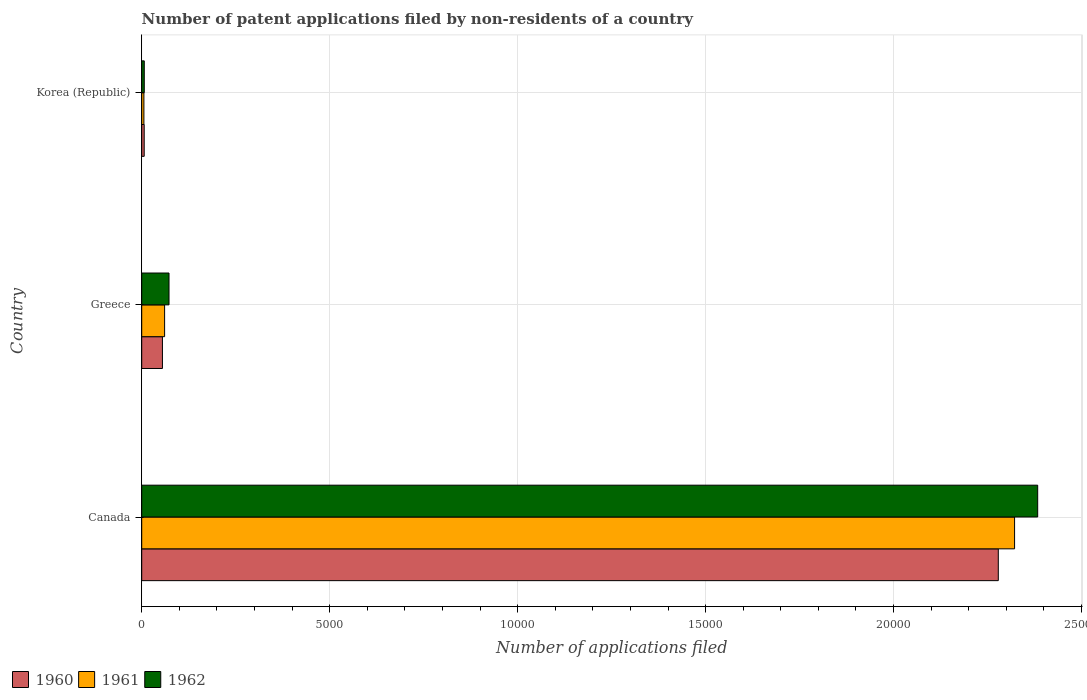How many different coloured bars are there?
Ensure brevity in your answer.  3. How many groups of bars are there?
Your answer should be very brief. 3. How many bars are there on the 1st tick from the top?
Offer a terse response. 3. What is the label of the 1st group of bars from the top?
Provide a succinct answer. Korea (Republic). In how many cases, is the number of bars for a given country not equal to the number of legend labels?
Ensure brevity in your answer.  0. What is the number of applications filed in 1962 in Korea (Republic)?
Offer a terse response. 68. Across all countries, what is the maximum number of applications filed in 1960?
Provide a short and direct response. 2.28e+04. In which country was the number of applications filed in 1962 maximum?
Make the answer very short. Canada. In which country was the number of applications filed in 1960 minimum?
Keep it short and to the point. Korea (Republic). What is the total number of applications filed in 1961 in the graph?
Give a very brief answer. 2.39e+04. What is the difference between the number of applications filed in 1961 in Canada and that in Greece?
Your answer should be compact. 2.26e+04. What is the difference between the number of applications filed in 1961 in Canada and the number of applications filed in 1960 in Korea (Republic)?
Your response must be concise. 2.32e+04. What is the average number of applications filed in 1960 per country?
Ensure brevity in your answer.  7801. What is the difference between the number of applications filed in 1960 and number of applications filed in 1961 in Korea (Republic)?
Your answer should be very brief. 8. What is the ratio of the number of applications filed in 1960 in Greece to that in Korea (Republic)?
Provide a short and direct response. 8.35. What is the difference between the highest and the second highest number of applications filed in 1962?
Give a very brief answer. 2.31e+04. What is the difference between the highest and the lowest number of applications filed in 1960?
Offer a terse response. 2.27e+04. Are all the bars in the graph horizontal?
Give a very brief answer. Yes. Are the values on the major ticks of X-axis written in scientific E-notation?
Offer a very short reply. No. Where does the legend appear in the graph?
Your answer should be compact. Bottom left. How many legend labels are there?
Your response must be concise. 3. What is the title of the graph?
Offer a very short reply. Number of patent applications filed by non-residents of a country. What is the label or title of the X-axis?
Ensure brevity in your answer.  Number of applications filed. What is the label or title of the Y-axis?
Ensure brevity in your answer.  Country. What is the Number of applications filed in 1960 in Canada?
Offer a terse response. 2.28e+04. What is the Number of applications filed in 1961 in Canada?
Provide a short and direct response. 2.32e+04. What is the Number of applications filed of 1962 in Canada?
Offer a very short reply. 2.38e+04. What is the Number of applications filed in 1960 in Greece?
Keep it short and to the point. 551. What is the Number of applications filed of 1961 in Greece?
Your answer should be compact. 609. What is the Number of applications filed in 1962 in Greece?
Offer a very short reply. 726. What is the Number of applications filed of 1961 in Korea (Republic)?
Ensure brevity in your answer.  58. What is the Number of applications filed in 1962 in Korea (Republic)?
Ensure brevity in your answer.  68. Across all countries, what is the maximum Number of applications filed of 1960?
Ensure brevity in your answer.  2.28e+04. Across all countries, what is the maximum Number of applications filed in 1961?
Offer a very short reply. 2.32e+04. Across all countries, what is the maximum Number of applications filed of 1962?
Offer a very short reply. 2.38e+04. Across all countries, what is the minimum Number of applications filed in 1960?
Your response must be concise. 66. Across all countries, what is the minimum Number of applications filed in 1962?
Your answer should be compact. 68. What is the total Number of applications filed in 1960 in the graph?
Your answer should be very brief. 2.34e+04. What is the total Number of applications filed of 1961 in the graph?
Keep it short and to the point. 2.39e+04. What is the total Number of applications filed of 1962 in the graph?
Your response must be concise. 2.46e+04. What is the difference between the Number of applications filed of 1960 in Canada and that in Greece?
Your response must be concise. 2.22e+04. What is the difference between the Number of applications filed of 1961 in Canada and that in Greece?
Provide a short and direct response. 2.26e+04. What is the difference between the Number of applications filed in 1962 in Canada and that in Greece?
Your answer should be compact. 2.31e+04. What is the difference between the Number of applications filed of 1960 in Canada and that in Korea (Republic)?
Make the answer very short. 2.27e+04. What is the difference between the Number of applications filed in 1961 in Canada and that in Korea (Republic)?
Provide a short and direct response. 2.32e+04. What is the difference between the Number of applications filed in 1962 in Canada and that in Korea (Republic)?
Offer a very short reply. 2.38e+04. What is the difference between the Number of applications filed of 1960 in Greece and that in Korea (Republic)?
Provide a short and direct response. 485. What is the difference between the Number of applications filed in 1961 in Greece and that in Korea (Republic)?
Provide a short and direct response. 551. What is the difference between the Number of applications filed of 1962 in Greece and that in Korea (Republic)?
Ensure brevity in your answer.  658. What is the difference between the Number of applications filed in 1960 in Canada and the Number of applications filed in 1961 in Greece?
Offer a very short reply. 2.22e+04. What is the difference between the Number of applications filed in 1960 in Canada and the Number of applications filed in 1962 in Greece?
Provide a short and direct response. 2.21e+04. What is the difference between the Number of applications filed in 1961 in Canada and the Number of applications filed in 1962 in Greece?
Ensure brevity in your answer.  2.25e+04. What is the difference between the Number of applications filed in 1960 in Canada and the Number of applications filed in 1961 in Korea (Republic)?
Your answer should be very brief. 2.27e+04. What is the difference between the Number of applications filed of 1960 in Canada and the Number of applications filed of 1962 in Korea (Republic)?
Your answer should be compact. 2.27e+04. What is the difference between the Number of applications filed in 1961 in Canada and the Number of applications filed in 1962 in Korea (Republic)?
Your answer should be compact. 2.32e+04. What is the difference between the Number of applications filed in 1960 in Greece and the Number of applications filed in 1961 in Korea (Republic)?
Keep it short and to the point. 493. What is the difference between the Number of applications filed in 1960 in Greece and the Number of applications filed in 1962 in Korea (Republic)?
Give a very brief answer. 483. What is the difference between the Number of applications filed of 1961 in Greece and the Number of applications filed of 1962 in Korea (Republic)?
Make the answer very short. 541. What is the average Number of applications filed of 1960 per country?
Provide a short and direct response. 7801. What is the average Number of applications filed of 1961 per country?
Make the answer very short. 7962. What is the average Number of applications filed of 1962 per country?
Keep it short and to the point. 8209.33. What is the difference between the Number of applications filed of 1960 and Number of applications filed of 1961 in Canada?
Give a very brief answer. -433. What is the difference between the Number of applications filed of 1960 and Number of applications filed of 1962 in Canada?
Offer a very short reply. -1048. What is the difference between the Number of applications filed of 1961 and Number of applications filed of 1962 in Canada?
Keep it short and to the point. -615. What is the difference between the Number of applications filed in 1960 and Number of applications filed in 1961 in Greece?
Provide a short and direct response. -58. What is the difference between the Number of applications filed in 1960 and Number of applications filed in 1962 in Greece?
Your response must be concise. -175. What is the difference between the Number of applications filed of 1961 and Number of applications filed of 1962 in Greece?
Keep it short and to the point. -117. What is the difference between the Number of applications filed of 1960 and Number of applications filed of 1962 in Korea (Republic)?
Give a very brief answer. -2. What is the ratio of the Number of applications filed of 1960 in Canada to that in Greece?
Ensure brevity in your answer.  41.35. What is the ratio of the Number of applications filed of 1961 in Canada to that in Greece?
Provide a short and direct response. 38.13. What is the ratio of the Number of applications filed in 1962 in Canada to that in Greece?
Provide a succinct answer. 32.83. What is the ratio of the Number of applications filed of 1960 in Canada to that in Korea (Republic)?
Keep it short and to the point. 345.24. What is the ratio of the Number of applications filed of 1961 in Canada to that in Korea (Republic)?
Give a very brief answer. 400.33. What is the ratio of the Number of applications filed in 1962 in Canada to that in Korea (Republic)?
Keep it short and to the point. 350.5. What is the ratio of the Number of applications filed in 1960 in Greece to that in Korea (Republic)?
Keep it short and to the point. 8.35. What is the ratio of the Number of applications filed of 1961 in Greece to that in Korea (Republic)?
Provide a succinct answer. 10.5. What is the ratio of the Number of applications filed of 1962 in Greece to that in Korea (Republic)?
Offer a terse response. 10.68. What is the difference between the highest and the second highest Number of applications filed in 1960?
Make the answer very short. 2.22e+04. What is the difference between the highest and the second highest Number of applications filed of 1961?
Offer a very short reply. 2.26e+04. What is the difference between the highest and the second highest Number of applications filed of 1962?
Offer a terse response. 2.31e+04. What is the difference between the highest and the lowest Number of applications filed of 1960?
Ensure brevity in your answer.  2.27e+04. What is the difference between the highest and the lowest Number of applications filed of 1961?
Ensure brevity in your answer.  2.32e+04. What is the difference between the highest and the lowest Number of applications filed in 1962?
Offer a very short reply. 2.38e+04. 